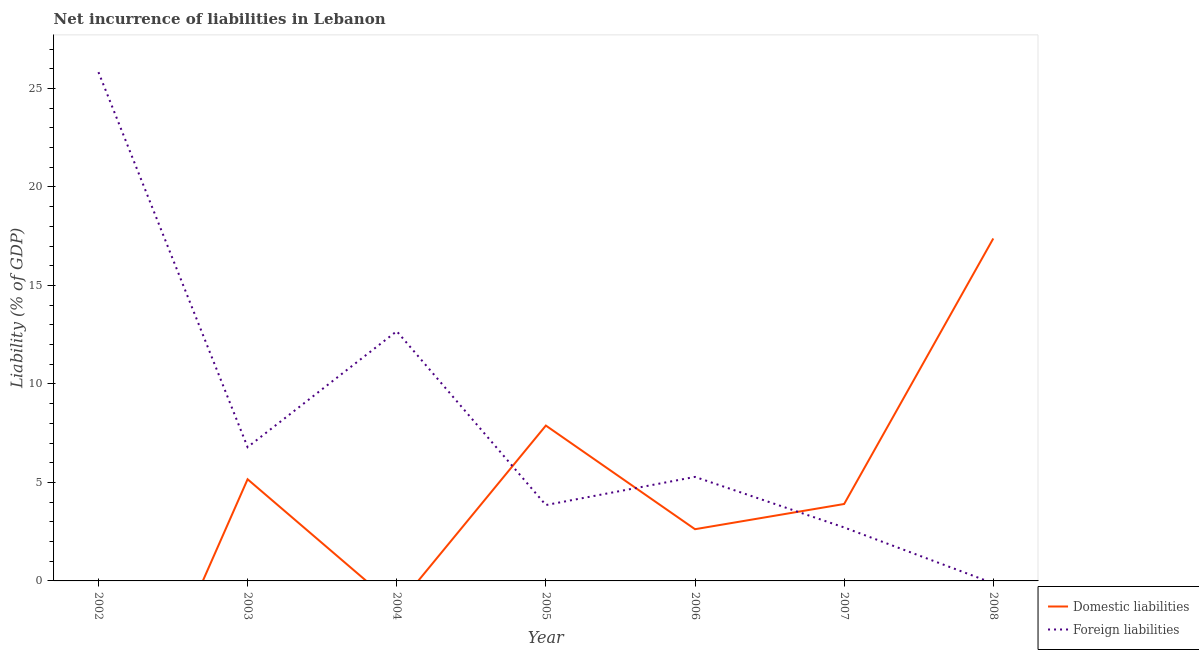How many different coloured lines are there?
Offer a terse response. 2. Does the line corresponding to incurrence of domestic liabilities intersect with the line corresponding to incurrence of foreign liabilities?
Provide a succinct answer. Yes. What is the incurrence of foreign liabilities in 2004?
Your response must be concise. 12.68. Across all years, what is the maximum incurrence of foreign liabilities?
Ensure brevity in your answer.  25.83. What is the total incurrence of domestic liabilities in the graph?
Make the answer very short. 36.96. What is the difference between the incurrence of foreign liabilities in 2005 and that in 2006?
Make the answer very short. -1.43. What is the difference between the incurrence of foreign liabilities in 2006 and the incurrence of domestic liabilities in 2002?
Your answer should be very brief. 5.28. What is the average incurrence of foreign liabilities per year?
Your answer should be very brief. 8.16. In the year 2006, what is the difference between the incurrence of foreign liabilities and incurrence of domestic liabilities?
Your answer should be very brief. 2.65. In how many years, is the incurrence of domestic liabilities greater than 18 %?
Make the answer very short. 0. What is the ratio of the incurrence of foreign liabilities in 2002 to that in 2004?
Offer a terse response. 2.04. What is the difference between the highest and the second highest incurrence of domestic liabilities?
Your answer should be compact. 9.5. What is the difference between the highest and the lowest incurrence of foreign liabilities?
Offer a very short reply. 25.83. In how many years, is the incurrence of foreign liabilities greater than the average incurrence of foreign liabilities taken over all years?
Ensure brevity in your answer.  2. Is the sum of the incurrence of domestic liabilities in 2003 and 2008 greater than the maximum incurrence of foreign liabilities across all years?
Ensure brevity in your answer.  No. How many years are there in the graph?
Provide a short and direct response. 7. What is the difference between two consecutive major ticks on the Y-axis?
Ensure brevity in your answer.  5. Does the graph contain grids?
Provide a succinct answer. No. Where does the legend appear in the graph?
Make the answer very short. Bottom right. What is the title of the graph?
Provide a short and direct response. Net incurrence of liabilities in Lebanon. What is the label or title of the X-axis?
Ensure brevity in your answer.  Year. What is the label or title of the Y-axis?
Ensure brevity in your answer.  Liability (% of GDP). What is the Liability (% of GDP) of Domestic liabilities in 2002?
Ensure brevity in your answer.  0. What is the Liability (% of GDP) of Foreign liabilities in 2002?
Give a very brief answer. 25.83. What is the Liability (% of GDP) in Domestic liabilities in 2003?
Give a very brief answer. 5.16. What is the Liability (% of GDP) of Foreign liabilities in 2003?
Your answer should be very brief. 6.79. What is the Liability (% of GDP) of Domestic liabilities in 2004?
Provide a succinct answer. 0. What is the Liability (% of GDP) in Foreign liabilities in 2004?
Offer a terse response. 12.68. What is the Liability (% of GDP) in Domestic liabilities in 2005?
Provide a succinct answer. 7.89. What is the Liability (% of GDP) of Foreign liabilities in 2005?
Make the answer very short. 3.85. What is the Liability (% of GDP) of Domestic liabilities in 2006?
Give a very brief answer. 2.63. What is the Liability (% of GDP) in Foreign liabilities in 2006?
Your response must be concise. 5.28. What is the Liability (% of GDP) in Domestic liabilities in 2007?
Give a very brief answer. 3.9. What is the Liability (% of GDP) in Foreign liabilities in 2007?
Ensure brevity in your answer.  2.71. What is the Liability (% of GDP) of Domestic liabilities in 2008?
Keep it short and to the point. 17.38. What is the Liability (% of GDP) in Foreign liabilities in 2008?
Offer a terse response. 0. Across all years, what is the maximum Liability (% of GDP) of Domestic liabilities?
Keep it short and to the point. 17.38. Across all years, what is the maximum Liability (% of GDP) in Foreign liabilities?
Provide a short and direct response. 25.83. Across all years, what is the minimum Liability (% of GDP) in Domestic liabilities?
Give a very brief answer. 0. What is the total Liability (% of GDP) in Domestic liabilities in the graph?
Make the answer very short. 36.96. What is the total Liability (% of GDP) in Foreign liabilities in the graph?
Ensure brevity in your answer.  57.14. What is the difference between the Liability (% of GDP) in Foreign liabilities in 2002 and that in 2003?
Provide a short and direct response. 19.03. What is the difference between the Liability (% of GDP) of Foreign liabilities in 2002 and that in 2004?
Provide a succinct answer. 13.15. What is the difference between the Liability (% of GDP) of Foreign liabilities in 2002 and that in 2005?
Provide a succinct answer. 21.97. What is the difference between the Liability (% of GDP) of Foreign liabilities in 2002 and that in 2006?
Keep it short and to the point. 20.54. What is the difference between the Liability (% of GDP) in Foreign liabilities in 2002 and that in 2007?
Ensure brevity in your answer.  23.11. What is the difference between the Liability (% of GDP) in Foreign liabilities in 2003 and that in 2004?
Give a very brief answer. -5.89. What is the difference between the Liability (% of GDP) of Domestic liabilities in 2003 and that in 2005?
Your answer should be compact. -2.73. What is the difference between the Liability (% of GDP) in Foreign liabilities in 2003 and that in 2005?
Give a very brief answer. 2.94. What is the difference between the Liability (% of GDP) in Domestic liabilities in 2003 and that in 2006?
Offer a terse response. 2.54. What is the difference between the Liability (% of GDP) of Foreign liabilities in 2003 and that in 2006?
Your answer should be compact. 1.51. What is the difference between the Liability (% of GDP) in Domestic liabilities in 2003 and that in 2007?
Ensure brevity in your answer.  1.26. What is the difference between the Liability (% of GDP) of Foreign liabilities in 2003 and that in 2007?
Your answer should be compact. 4.08. What is the difference between the Liability (% of GDP) of Domestic liabilities in 2003 and that in 2008?
Make the answer very short. -12.22. What is the difference between the Liability (% of GDP) of Foreign liabilities in 2004 and that in 2005?
Your answer should be very brief. 8.82. What is the difference between the Liability (% of GDP) in Foreign liabilities in 2004 and that in 2006?
Keep it short and to the point. 7.4. What is the difference between the Liability (% of GDP) in Foreign liabilities in 2004 and that in 2007?
Ensure brevity in your answer.  9.96. What is the difference between the Liability (% of GDP) in Domestic liabilities in 2005 and that in 2006?
Offer a terse response. 5.26. What is the difference between the Liability (% of GDP) of Foreign liabilities in 2005 and that in 2006?
Offer a terse response. -1.43. What is the difference between the Liability (% of GDP) of Domestic liabilities in 2005 and that in 2007?
Provide a short and direct response. 3.98. What is the difference between the Liability (% of GDP) of Foreign liabilities in 2005 and that in 2007?
Ensure brevity in your answer.  1.14. What is the difference between the Liability (% of GDP) in Domestic liabilities in 2005 and that in 2008?
Offer a terse response. -9.5. What is the difference between the Liability (% of GDP) in Domestic liabilities in 2006 and that in 2007?
Offer a very short reply. -1.28. What is the difference between the Liability (% of GDP) in Foreign liabilities in 2006 and that in 2007?
Make the answer very short. 2.57. What is the difference between the Liability (% of GDP) of Domestic liabilities in 2006 and that in 2008?
Offer a terse response. -14.76. What is the difference between the Liability (% of GDP) in Domestic liabilities in 2007 and that in 2008?
Ensure brevity in your answer.  -13.48. What is the difference between the Liability (% of GDP) of Domestic liabilities in 2003 and the Liability (% of GDP) of Foreign liabilities in 2004?
Offer a terse response. -7.52. What is the difference between the Liability (% of GDP) in Domestic liabilities in 2003 and the Liability (% of GDP) in Foreign liabilities in 2005?
Offer a terse response. 1.31. What is the difference between the Liability (% of GDP) of Domestic liabilities in 2003 and the Liability (% of GDP) of Foreign liabilities in 2006?
Offer a very short reply. -0.12. What is the difference between the Liability (% of GDP) of Domestic liabilities in 2003 and the Liability (% of GDP) of Foreign liabilities in 2007?
Provide a short and direct response. 2.45. What is the difference between the Liability (% of GDP) of Domestic liabilities in 2005 and the Liability (% of GDP) of Foreign liabilities in 2006?
Offer a very short reply. 2.61. What is the difference between the Liability (% of GDP) of Domestic liabilities in 2005 and the Liability (% of GDP) of Foreign liabilities in 2007?
Your response must be concise. 5.17. What is the difference between the Liability (% of GDP) in Domestic liabilities in 2006 and the Liability (% of GDP) in Foreign liabilities in 2007?
Your answer should be compact. -0.09. What is the average Liability (% of GDP) in Domestic liabilities per year?
Give a very brief answer. 5.28. What is the average Liability (% of GDP) in Foreign liabilities per year?
Provide a short and direct response. 8.16. In the year 2003, what is the difference between the Liability (% of GDP) of Domestic liabilities and Liability (% of GDP) of Foreign liabilities?
Give a very brief answer. -1.63. In the year 2005, what is the difference between the Liability (% of GDP) of Domestic liabilities and Liability (% of GDP) of Foreign liabilities?
Offer a very short reply. 4.03. In the year 2006, what is the difference between the Liability (% of GDP) in Domestic liabilities and Liability (% of GDP) in Foreign liabilities?
Your answer should be compact. -2.65. In the year 2007, what is the difference between the Liability (% of GDP) in Domestic liabilities and Liability (% of GDP) in Foreign liabilities?
Provide a short and direct response. 1.19. What is the ratio of the Liability (% of GDP) of Foreign liabilities in 2002 to that in 2003?
Provide a succinct answer. 3.8. What is the ratio of the Liability (% of GDP) of Foreign liabilities in 2002 to that in 2004?
Make the answer very short. 2.04. What is the ratio of the Liability (% of GDP) of Foreign liabilities in 2002 to that in 2005?
Make the answer very short. 6.71. What is the ratio of the Liability (% of GDP) in Foreign liabilities in 2002 to that in 2006?
Keep it short and to the point. 4.89. What is the ratio of the Liability (% of GDP) of Foreign liabilities in 2002 to that in 2007?
Ensure brevity in your answer.  9.52. What is the ratio of the Liability (% of GDP) in Foreign liabilities in 2003 to that in 2004?
Your answer should be very brief. 0.54. What is the ratio of the Liability (% of GDP) of Domestic liabilities in 2003 to that in 2005?
Your answer should be very brief. 0.65. What is the ratio of the Liability (% of GDP) of Foreign liabilities in 2003 to that in 2005?
Ensure brevity in your answer.  1.76. What is the ratio of the Liability (% of GDP) of Domestic liabilities in 2003 to that in 2006?
Keep it short and to the point. 1.97. What is the ratio of the Liability (% of GDP) in Foreign liabilities in 2003 to that in 2006?
Your response must be concise. 1.29. What is the ratio of the Liability (% of GDP) of Domestic liabilities in 2003 to that in 2007?
Provide a short and direct response. 1.32. What is the ratio of the Liability (% of GDP) of Foreign liabilities in 2003 to that in 2007?
Ensure brevity in your answer.  2.5. What is the ratio of the Liability (% of GDP) in Domestic liabilities in 2003 to that in 2008?
Ensure brevity in your answer.  0.3. What is the ratio of the Liability (% of GDP) of Foreign liabilities in 2004 to that in 2005?
Provide a succinct answer. 3.29. What is the ratio of the Liability (% of GDP) of Foreign liabilities in 2004 to that in 2006?
Provide a succinct answer. 2.4. What is the ratio of the Liability (% of GDP) in Foreign liabilities in 2004 to that in 2007?
Your answer should be compact. 4.67. What is the ratio of the Liability (% of GDP) of Domestic liabilities in 2005 to that in 2006?
Make the answer very short. 3. What is the ratio of the Liability (% of GDP) in Foreign liabilities in 2005 to that in 2006?
Provide a short and direct response. 0.73. What is the ratio of the Liability (% of GDP) of Domestic liabilities in 2005 to that in 2007?
Give a very brief answer. 2.02. What is the ratio of the Liability (% of GDP) of Foreign liabilities in 2005 to that in 2007?
Give a very brief answer. 1.42. What is the ratio of the Liability (% of GDP) in Domestic liabilities in 2005 to that in 2008?
Your answer should be compact. 0.45. What is the ratio of the Liability (% of GDP) in Domestic liabilities in 2006 to that in 2007?
Keep it short and to the point. 0.67. What is the ratio of the Liability (% of GDP) of Foreign liabilities in 2006 to that in 2007?
Offer a very short reply. 1.95. What is the ratio of the Liability (% of GDP) of Domestic liabilities in 2006 to that in 2008?
Give a very brief answer. 0.15. What is the ratio of the Liability (% of GDP) of Domestic liabilities in 2007 to that in 2008?
Ensure brevity in your answer.  0.22. What is the difference between the highest and the second highest Liability (% of GDP) of Domestic liabilities?
Provide a short and direct response. 9.5. What is the difference between the highest and the second highest Liability (% of GDP) in Foreign liabilities?
Ensure brevity in your answer.  13.15. What is the difference between the highest and the lowest Liability (% of GDP) in Domestic liabilities?
Your answer should be compact. 17.38. What is the difference between the highest and the lowest Liability (% of GDP) of Foreign liabilities?
Provide a short and direct response. 25.82. 